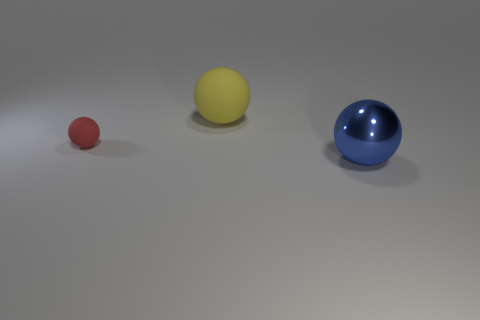Is the material of the tiny thing in front of the big yellow thing the same as the yellow object?
Your response must be concise. Yes. What is the size of the red ball?
Provide a succinct answer. Small. How many blocks are either tiny rubber things or big yellow matte objects?
Make the answer very short. 0. Are there the same number of tiny objects that are in front of the small rubber sphere and shiny balls behind the big rubber ball?
Provide a succinct answer. Yes. What is the size of the other metal object that is the same shape as the tiny red object?
Offer a terse response. Large. What size is the object that is right of the red sphere and in front of the yellow ball?
Your answer should be very brief. Large. Are there any large spheres behind the small rubber ball?
Give a very brief answer. Yes. What number of things are either rubber balls that are left of the large yellow matte ball or yellow matte spheres?
Your answer should be very brief. 2. What number of red balls are on the left side of the big object in front of the yellow object?
Provide a short and direct response. 1. Are there fewer large rubber balls that are behind the yellow thing than large blue metal spheres that are behind the small sphere?
Provide a short and direct response. No. 